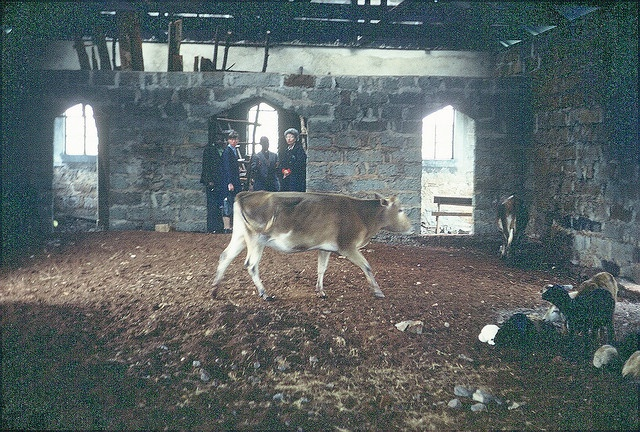Describe the objects in this image and their specific colors. I can see cow in black, gray, darkgray, and ivory tones, sheep in black, teal, navy, and darkgreen tones, people in black, blue, gray, and navy tones, cow in black, gray, and teal tones, and people in black, blue, gray, darkblue, and darkgray tones in this image. 